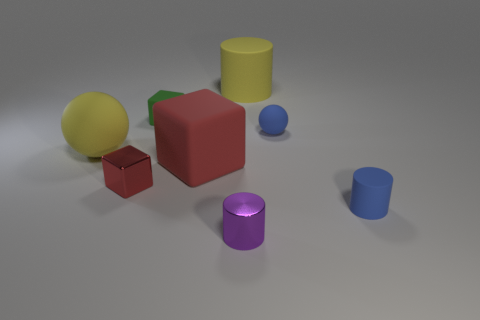Is the size of the blue cylinder the same as the metallic object behind the small matte cylinder?
Ensure brevity in your answer.  Yes. What number of matte objects are big yellow cylinders or yellow balls?
Your response must be concise. 2. Is there anything else that is the same material as the yellow ball?
Offer a terse response. Yes. There is a big rubber block; is it the same color as the tiny cube that is in front of the large yellow matte ball?
Offer a very short reply. Yes. The small green object is what shape?
Ensure brevity in your answer.  Cube. How big is the cylinder behind the ball behind the yellow thing that is in front of the large rubber cylinder?
Give a very brief answer. Large. There is a yellow rubber thing that is to the left of the purple cylinder; does it have the same shape as the small blue object in front of the big red block?
Offer a terse response. No. How many spheres are either large yellow rubber objects or blue objects?
Give a very brief answer. 2. What material is the cylinder in front of the tiny blue object that is on the right side of the ball to the right of the small purple shiny cylinder?
Provide a short and direct response. Metal. How many other things are there of the same size as the purple shiny thing?
Offer a very short reply. 4. 